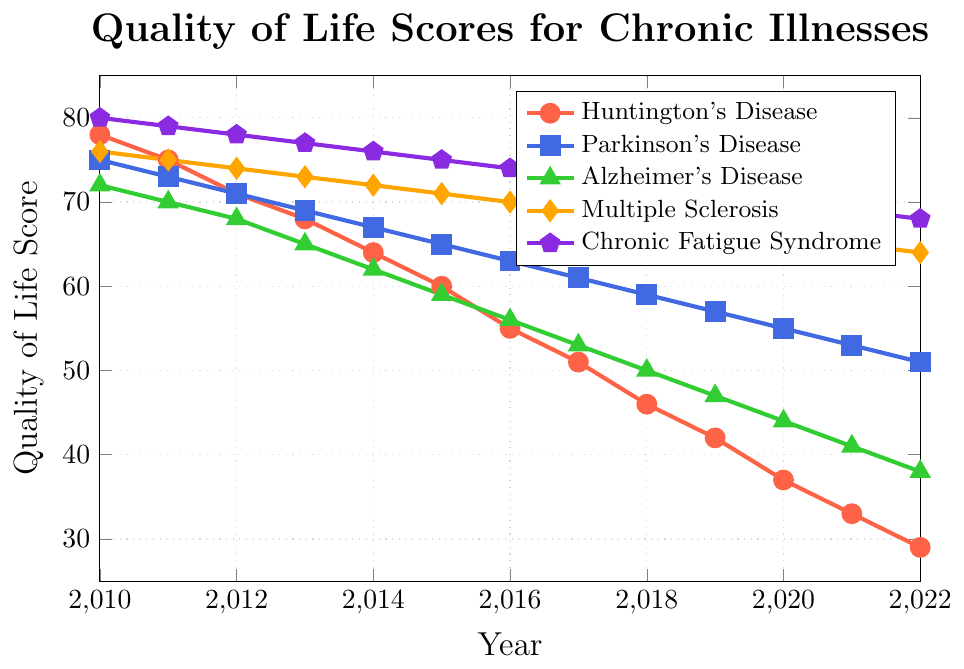Which condition shows the steepest decline in quality of life scores over the years? By visual assessment, Huntington's Disease has a fast and steep decline starting from a score of 78 in 2010 to 29 in 2022. This is a more pronounced drop compared to the other conditions.
Answer: Huntington's Disease What is the difference in the quality of life score for Huntington's Disease between 2010 and 2022? The score for Huntington's Disease was 78 in 2010 and dropped to 29 in 2022. So, the difference is 78 - 29.
Answer: 49 Between which two years did Multiple Sclerosis show the smallest change in quality of life score? Multiple Sclerosis has fairly stable scores changing by 1 every year for most of the years, but the smallest changes are between subsequent years where the score only decreases by 1 each time.
Answer: 2017 and 2018 Which condition had the highest quality of life score in 2016 and what was the score? According to the chart, Chronic Fatigue Syndrome had the highest score in 2016, which was 74.
Answer: Chronic Fatigue Syndrome, 74 How many years did it take for Parkinson's Disease to decline by 12 points? Parkinson's Disease started at 75 in 2010 and declined to 63 in 2016. The difference is 12 points, and it took from 2010 to 2016 to cover that change, basically 6 years.
Answer: 6 years What is the average quality of life score for Alzheimer's Disease over the plotted years? Add the scores from 2010 to 2022 and divide by the number of years: (72+70+68+65+62+59+56+53+50+47+44+41+38) / 13. Total is 725, thus average is 725/13.
Answer: 55.77 Which condition shows the least variability in quality of life scores over the years? Multiple Sclerosis shows the least variability as its scores range from 76 to 64, showing a gradual and consistent decline.
Answer: Multiple Sclerosis By how much did the quality of life score for Chronic Fatigue Syndrome decrease from 2010 to 2022? It decreased from 80 in 2010 to 68 in 2022. So, the decrease is 80 - 68.
Answer: 12 Which year did Huntington's Disease quality of life score fall below 50? By examining the chart, the quality of life score fell below 50 between 2016 and 2017, reaching 46 in 2018.
Answer: 2017 Which two conditions had the same quality of life score in 2013, and what was the score? Huntington's Disease and Parkinson's Disease both had a quality of life score of 68 in 2013.
Answer: Huntington's Disease and Parkinson's Disease, 68 